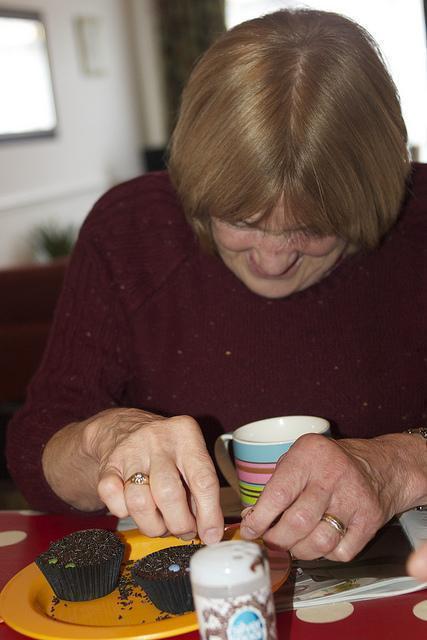How many cakes are there?
Give a very brief answer. 2. 